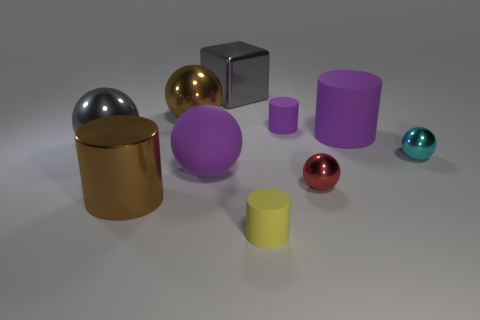There is a brown cylinder that is the same size as the metal cube; what material is it?
Provide a short and direct response. Metal. There is another tiny thing that is the same shape as the tiny cyan metal thing; what is it made of?
Your answer should be compact. Metal. What number of other things are the same size as the red thing?
Provide a short and direct response. 3. What size is the object that is the same color as the big cube?
Your answer should be very brief. Large. How many large metallic objects have the same color as the metal cube?
Your response must be concise. 1. There is a yellow rubber thing; what shape is it?
Provide a short and direct response. Cylinder. What color is the big object that is in front of the cyan shiny thing and behind the large metal cylinder?
Provide a succinct answer. Purple. What material is the purple ball?
Give a very brief answer. Rubber. There is a large brown metallic object in front of the gray sphere; what shape is it?
Your response must be concise. Cylinder. The sphere that is the same size as the cyan shiny thing is what color?
Provide a short and direct response. Red. 